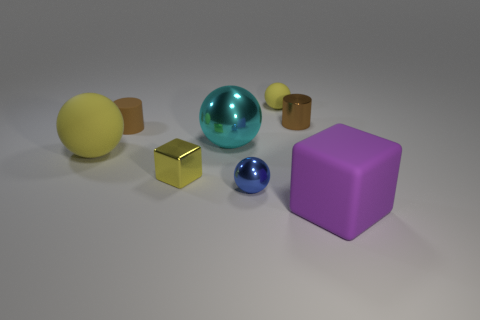Add 1 tiny brown rubber cylinders. How many objects exist? 9 Subtract all cubes. How many objects are left? 6 Add 1 yellow metallic cubes. How many yellow metallic cubes are left? 2 Add 5 small yellow matte spheres. How many small yellow matte spheres exist? 6 Subtract 1 blue spheres. How many objects are left? 7 Subtract all large shiny objects. Subtract all large cyan metallic objects. How many objects are left? 6 